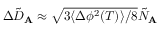<formula> <loc_0><loc_0><loc_500><loc_500>\Delta \tilde { D } _ { A } \approx \sqrt { 3 \langle \Delta \phi ^ { 2 } ( T ) \rangle / 8 } \tilde { N } _ { A }</formula> 